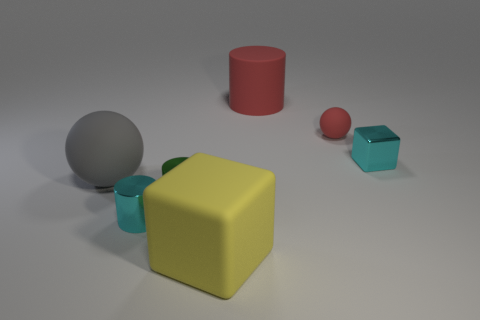Add 2 large rubber spheres. How many objects exist? 9 Subtract all cylinders. How many objects are left? 4 Subtract 0 purple blocks. How many objects are left? 7 Subtract all gray spheres. Subtract all big red cylinders. How many objects are left? 5 Add 1 large yellow blocks. How many large yellow blocks are left? 2 Add 1 brown blocks. How many brown blocks exist? 1 